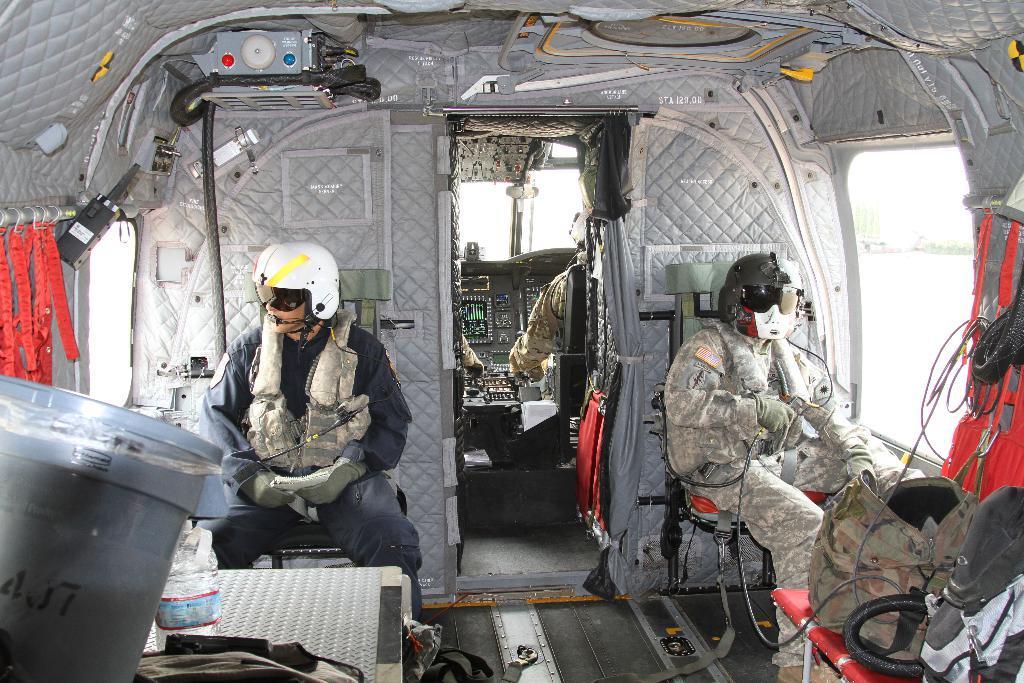Please provide a concise description of this image. In this image there are few people in the helicopter, there are a few bags on the tables and outside the helicopter there is a building. 